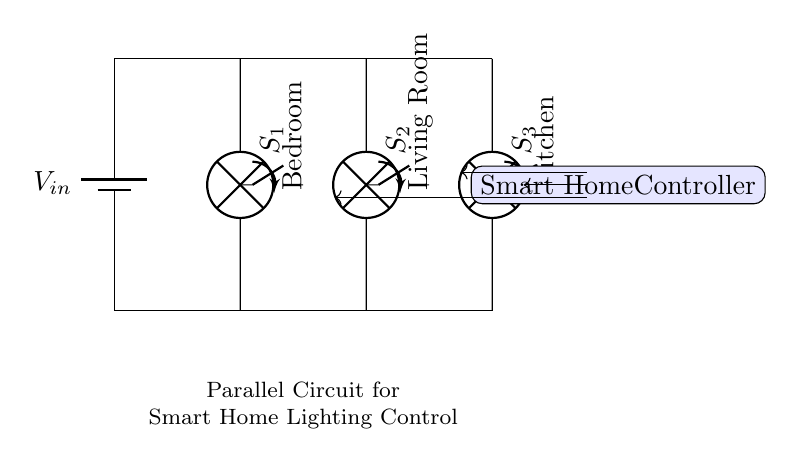What are the components used in this circuit? The circuit includes three lamps (for Bedroom, Living Room, and Kitchen), a battery (representing the voltage source), three switches (S1, S2, S3), and a Smart Home Controller.
Answer: lamps, battery, switches, Smart Home Controller What is the purpose of the switches in this circuit? The switches allow for individual control of each lamp in the circuit. When a switch is closed, the corresponding lamp lights up; if open, the lamp remains off.
Answer: Control of lamps How many lamps are in this parallel circuit? The circuit diagram shows three lamps connected in parallel for independent lighting control.
Answer: Three What does the Smart Home Controller do in this circuit? The Smart Home Controller manages the operation of the switches, allowing users to control the lamps remotely or based on pre-set conditions.
Answer: Manages lighting control If one lamp is off, what happens to the others? In a parallel circuit, if one lamp is turned off (switch open), the other lamps remain on and can be controlled independently due to their separate pathways.
Answer: Others remain on Where are the inputs and outputs in this circuit? The input is at the battery (voltage source), and the outputs are at each lamp where the light is produced when switches are closed.
Answer: Battery and lamps What type of circuit is represented here? This is a parallel circuit, where multiple components (lamps) are connected across the same voltage source but on separate branches, allowing for independent operation.
Answer: Parallel circuit 